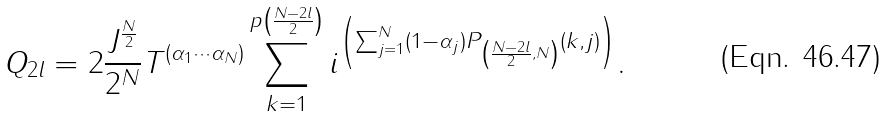Convert formula to latex. <formula><loc_0><loc_0><loc_500><loc_500>Q _ { 2 l } = 2 \frac { J ^ { \frac { N } { 2 } } } { 2 ^ { N } } T ^ { ( \alpha _ { 1 } \cdots \alpha _ { N } ) } \sum _ { k = 1 } ^ { p \left ( \frac { N - 2 l } { 2 } \right ) } i ^ { \left ( { \sum _ { j = 1 } ^ { N } ( 1 - \alpha _ { j } ) P _ { \left ( \frac { N - 2 l } { 2 } , N \right ) } ( k , j ) } \right ) } .</formula> 